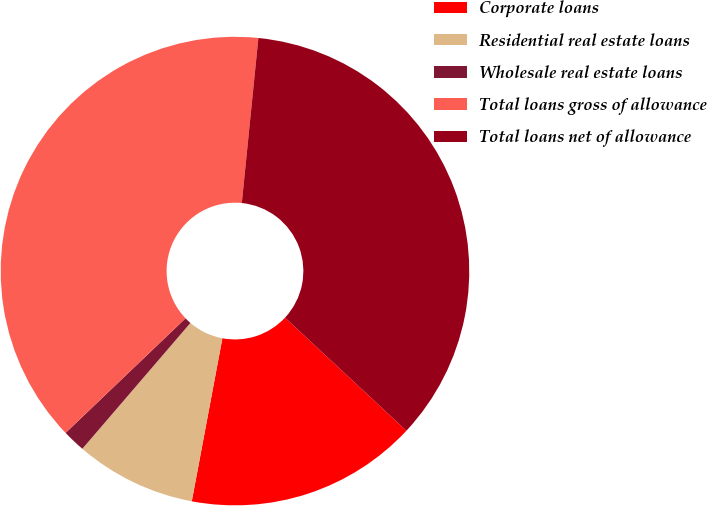<chart> <loc_0><loc_0><loc_500><loc_500><pie_chart><fcel>Corporate loans<fcel>Residential real estate loans<fcel>Wholesale real estate loans<fcel>Total loans gross of allowance<fcel>Total loans net of allowance<nl><fcel>16.02%<fcel>8.34%<fcel>1.57%<fcel>38.73%<fcel>35.34%<nl></chart> 